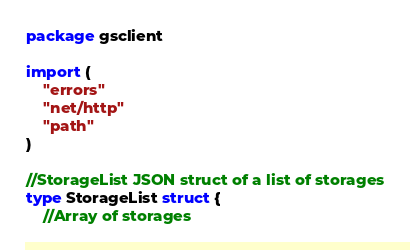Convert code to text. <code><loc_0><loc_0><loc_500><loc_500><_Go_>package gsclient

import (
	"errors"
	"net/http"
	"path"
)

//StorageList JSON struct of a list of storages
type StorageList struct {
	//Array of storages</code> 